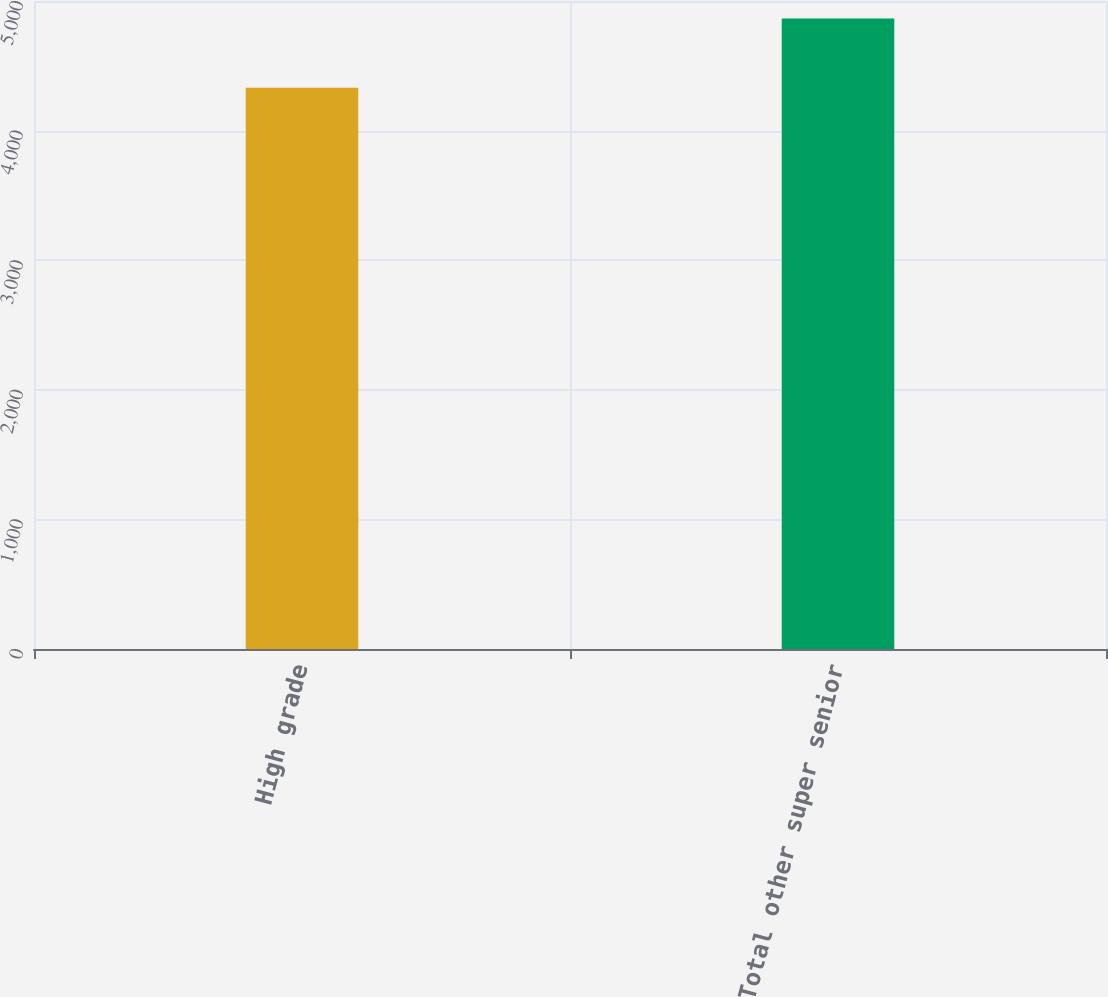Convert chart to OTSL. <chart><loc_0><loc_0><loc_500><loc_500><bar_chart><fcel>High grade<fcel>Total other super senior<nl><fcel>4330<fcel>4865<nl></chart> 